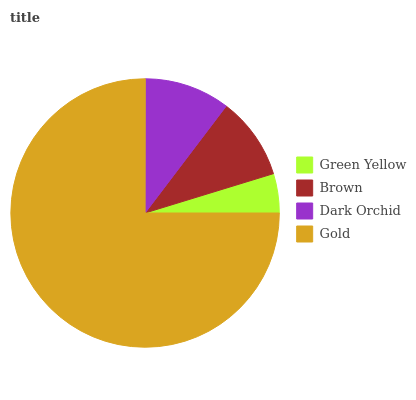Is Green Yellow the minimum?
Answer yes or no. Yes. Is Gold the maximum?
Answer yes or no. Yes. Is Brown the minimum?
Answer yes or no. No. Is Brown the maximum?
Answer yes or no. No. Is Brown greater than Green Yellow?
Answer yes or no. Yes. Is Green Yellow less than Brown?
Answer yes or no. Yes. Is Green Yellow greater than Brown?
Answer yes or no. No. Is Brown less than Green Yellow?
Answer yes or no. No. Is Dark Orchid the high median?
Answer yes or no. Yes. Is Brown the low median?
Answer yes or no. Yes. Is Brown the high median?
Answer yes or no. No. Is Green Yellow the low median?
Answer yes or no. No. 